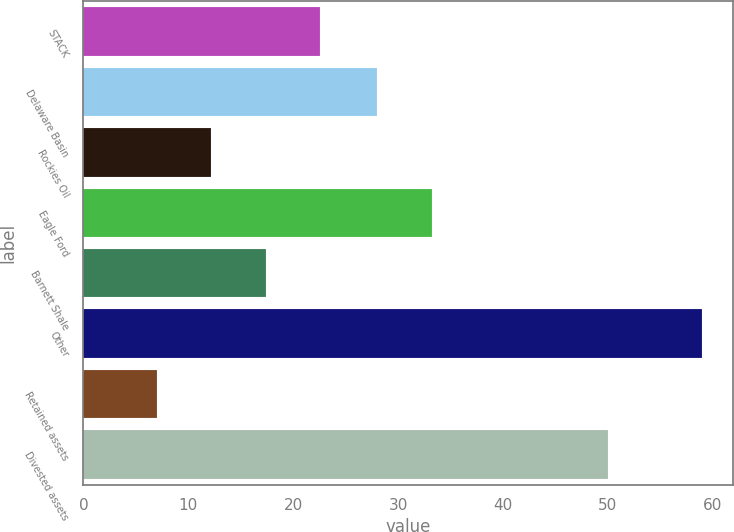Convert chart. <chart><loc_0><loc_0><loc_500><loc_500><bar_chart><fcel>STACK<fcel>Delaware Basin<fcel>Rockies Oil<fcel>Eagle Ford<fcel>Barnett Shale<fcel>Other<fcel>Retained assets<fcel>Divested assets<nl><fcel>22.6<fcel>28<fcel>12.2<fcel>33.2<fcel>17.4<fcel>59<fcel>7<fcel>50<nl></chart> 